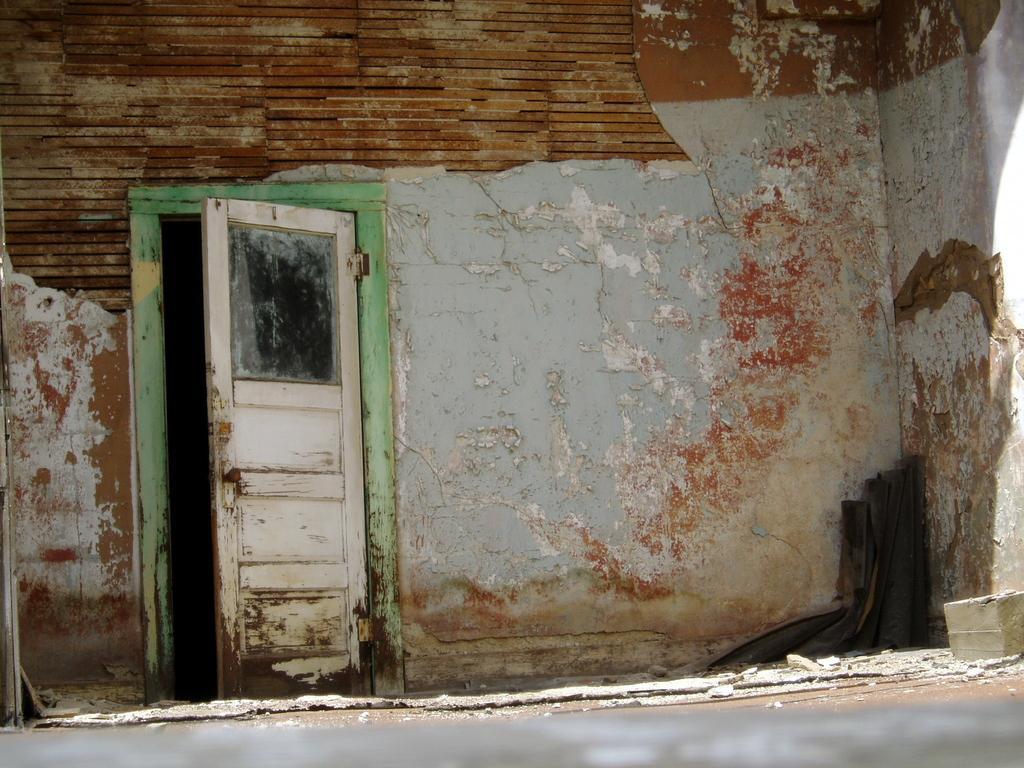Could you give a brief overview of what you see in this image? In this picture we can see the road, door and in the background we can see wall. 